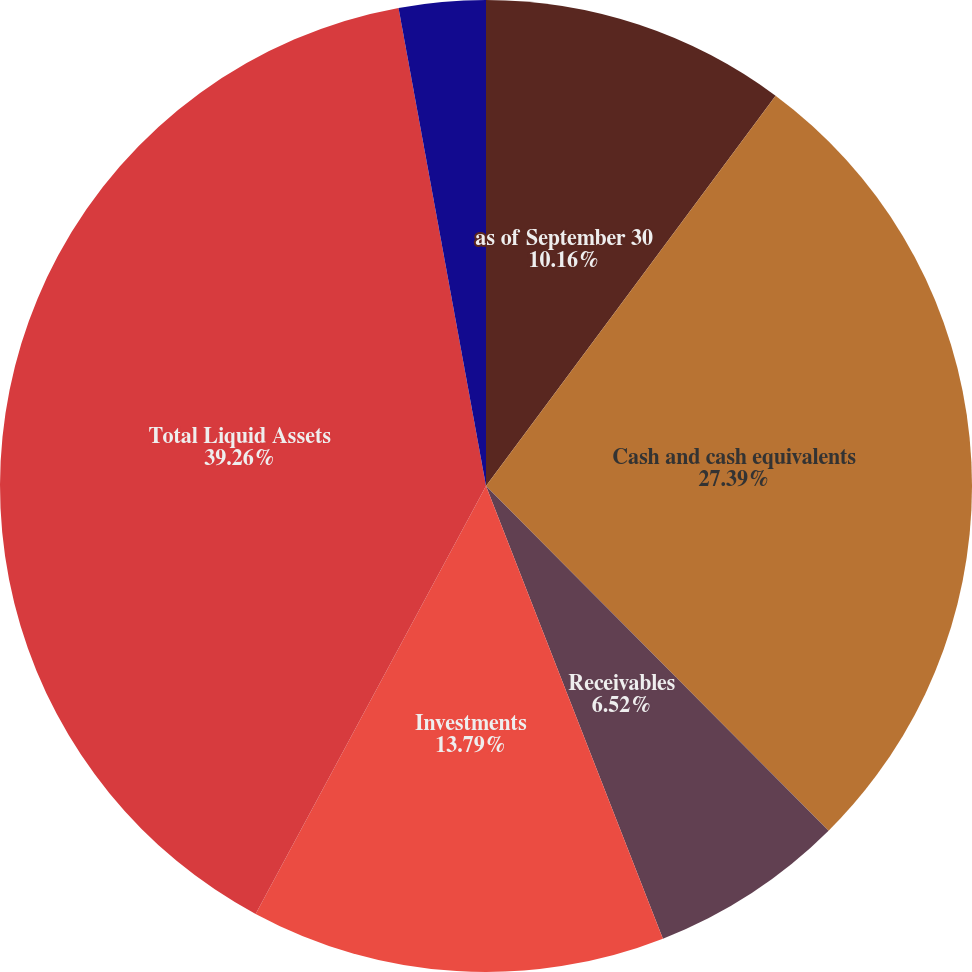Convert chart. <chart><loc_0><loc_0><loc_500><loc_500><pie_chart><fcel>as of September 30<fcel>Cash and cash equivalents<fcel>Receivables<fcel>Investments<fcel>Total Liquid Assets<fcel>Debt<nl><fcel>10.16%<fcel>27.39%<fcel>6.52%<fcel>13.79%<fcel>39.26%<fcel>2.88%<nl></chart> 